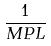Convert formula to latex. <formula><loc_0><loc_0><loc_500><loc_500>\frac { 1 } { M P L }</formula> 